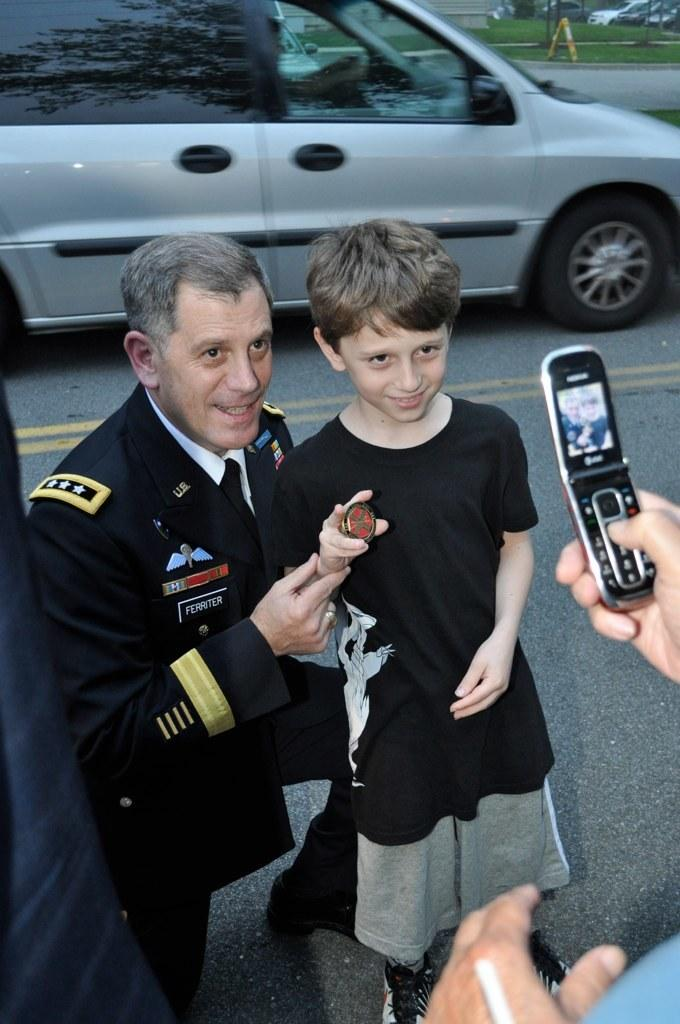How many people are in the image? There are two persons in the image. Can you describe the individuals in the image? One of the persons is a man, and the other person is a kid. What are the man and the kid doing in the image? Both the man and the kid are posing for a mobile. What can be seen in the background of the image? There is a car and grass in the background of the image. What type of treatment is the kid receiving in the image? There is no indication in the image that the kid is receiving any treatment; they are simply posing for a mobile with the man. 